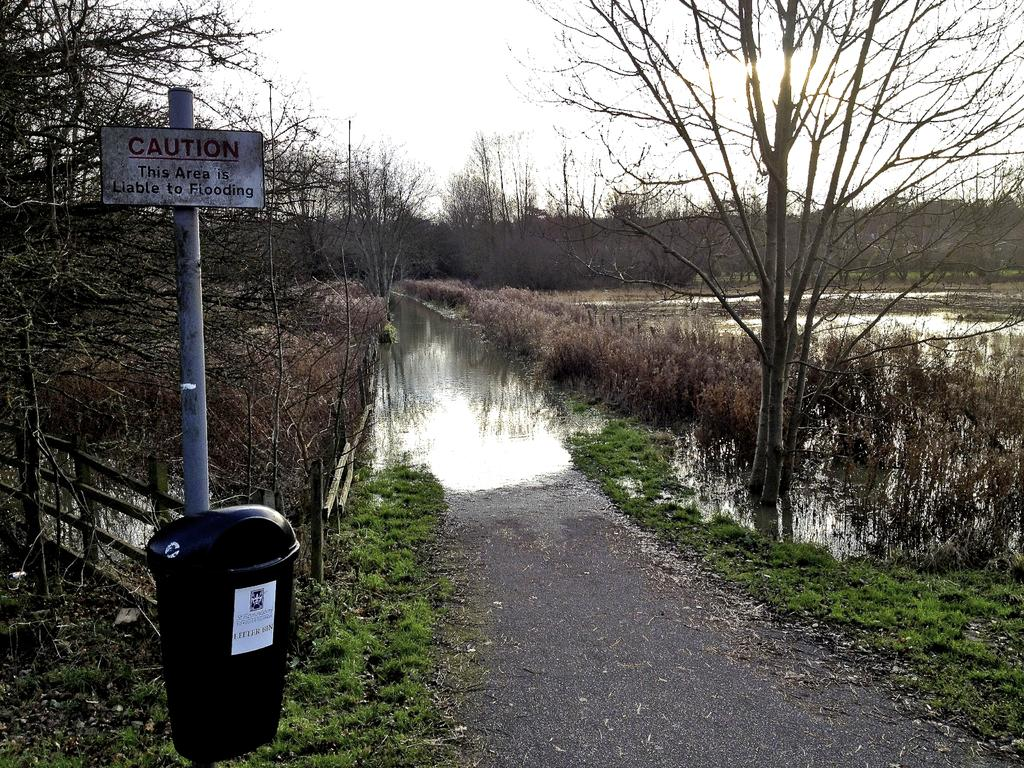<image>
Write a terse but informative summary of the picture. A flooded walkway with a garbage can and a sign that says Caution this Area is Liable to Flooding. 